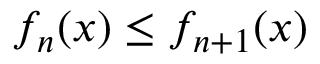Convert formula to latex. <formula><loc_0><loc_0><loc_500><loc_500>f _ { n } ( x ) \leq f _ { n + 1 } ( x )</formula> 